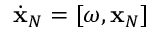Convert formula to latex. <formula><loc_0><loc_0><loc_500><loc_500>\dot { x } _ { N } = [ \omega , { x } _ { N } ]</formula> 